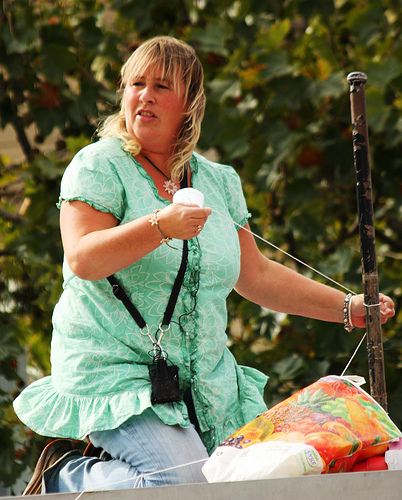<image>
Can you confirm if the shirt is under the string? No. The shirt is not positioned under the string. The vertical relationship between these objects is different. 